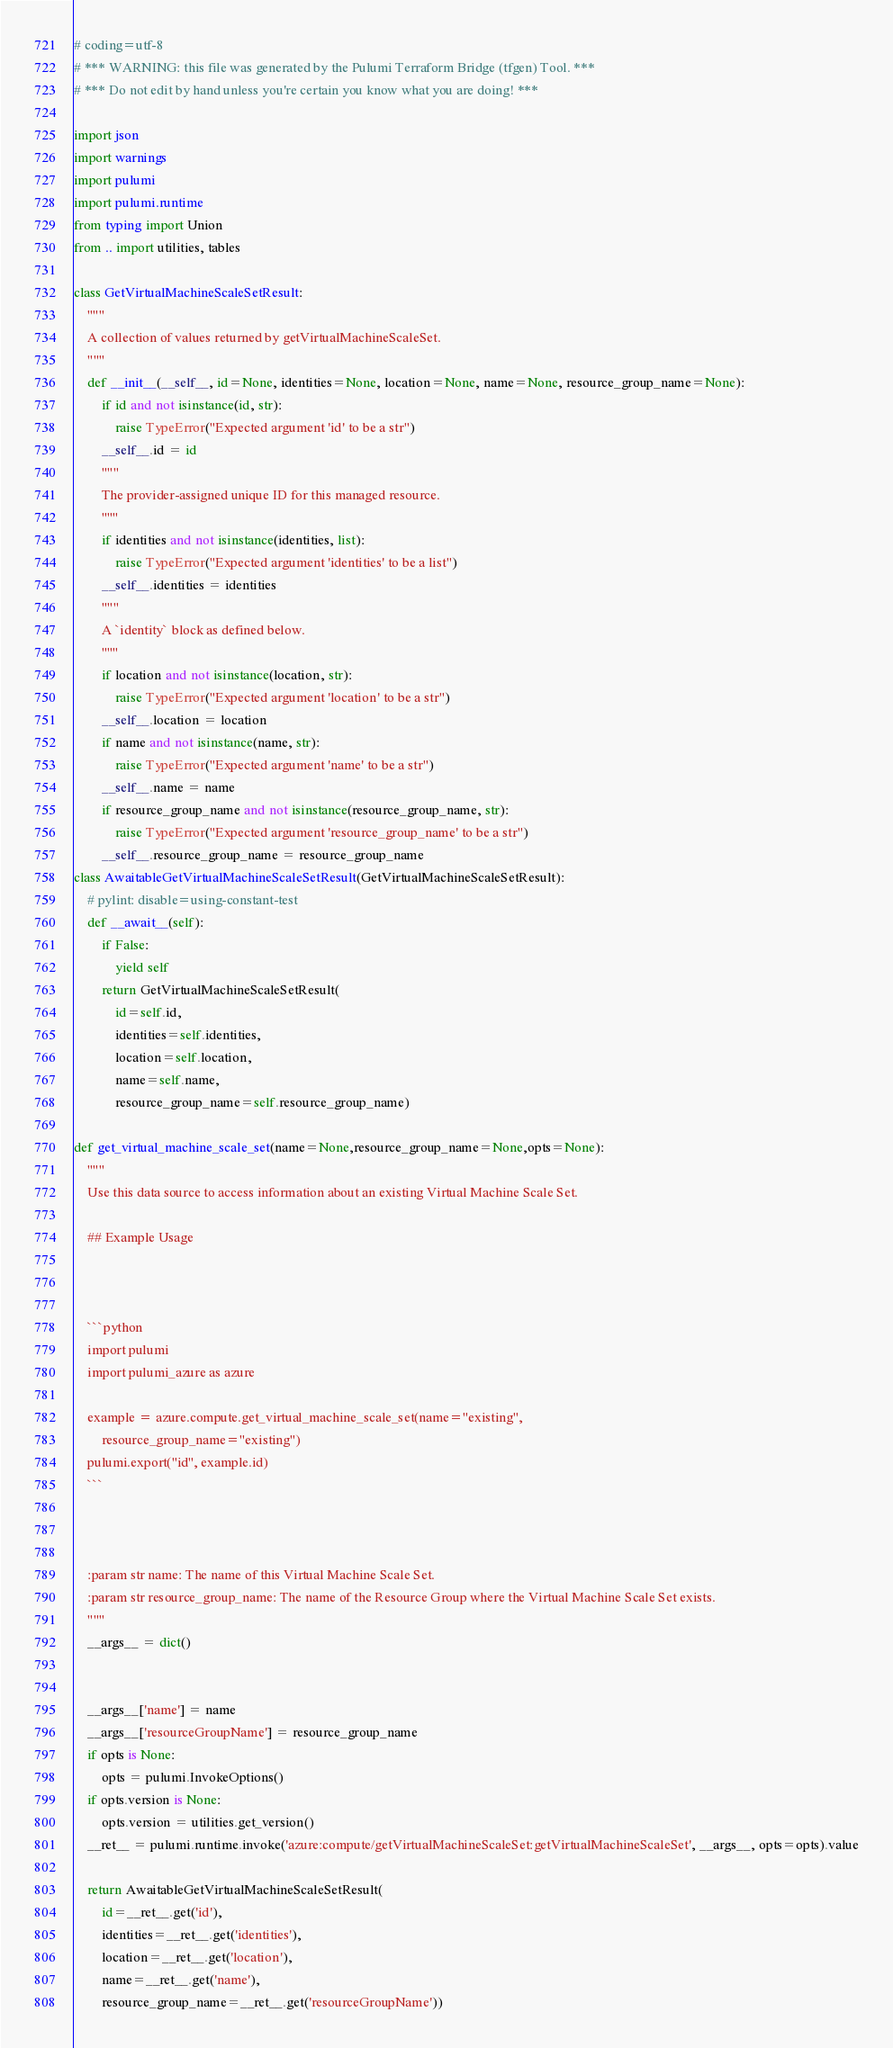Convert code to text. <code><loc_0><loc_0><loc_500><loc_500><_Python_># coding=utf-8
# *** WARNING: this file was generated by the Pulumi Terraform Bridge (tfgen) Tool. ***
# *** Do not edit by hand unless you're certain you know what you are doing! ***

import json
import warnings
import pulumi
import pulumi.runtime
from typing import Union
from .. import utilities, tables

class GetVirtualMachineScaleSetResult:
    """
    A collection of values returned by getVirtualMachineScaleSet.
    """
    def __init__(__self__, id=None, identities=None, location=None, name=None, resource_group_name=None):
        if id and not isinstance(id, str):
            raise TypeError("Expected argument 'id' to be a str")
        __self__.id = id
        """
        The provider-assigned unique ID for this managed resource.
        """
        if identities and not isinstance(identities, list):
            raise TypeError("Expected argument 'identities' to be a list")
        __self__.identities = identities
        """
        A `identity` block as defined below.
        """
        if location and not isinstance(location, str):
            raise TypeError("Expected argument 'location' to be a str")
        __self__.location = location
        if name and not isinstance(name, str):
            raise TypeError("Expected argument 'name' to be a str")
        __self__.name = name
        if resource_group_name and not isinstance(resource_group_name, str):
            raise TypeError("Expected argument 'resource_group_name' to be a str")
        __self__.resource_group_name = resource_group_name
class AwaitableGetVirtualMachineScaleSetResult(GetVirtualMachineScaleSetResult):
    # pylint: disable=using-constant-test
    def __await__(self):
        if False:
            yield self
        return GetVirtualMachineScaleSetResult(
            id=self.id,
            identities=self.identities,
            location=self.location,
            name=self.name,
            resource_group_name=self.resource_group_name)

def get_virtual_machine_scale_set(name=None,resource_group_name=None,opts=None):
    """
    Use this data source to access information about an existing Virtual Machine Scale Set.

    ## Example Usage



    ```python
    import pulumi
    import pulumi_azure as azure

    example = azure.compute.get_virtual_machine_scale_set(name="existing",
        resource_group_name="existing")
    pulumi.export("id", example.id)
    ```



    :param str name: The name of this Virtual Machine Scale Set.
    :param str resource_group_name: The name of the Resource Group where the Virtual Machine Scale Set exists.
    """
    __args__ = dict()


    __args__['name'] = name
    __args__['resourceGroupName'] = resource_group_name
    if opts is None:
        opts = pulumi.InvokeOptions()
    if opts.version is None:
        opts.version = utilities.get_version()
    __ret__ = pulumi.runtime.invoke('azure:compute/getVirtualMachineScaleSet:getVirtualMachineScaleSet', __args__, opts=opts).value

    return AwaitableGetVirtualMachineScaleSetResult(
        id=__ret__.get('id'),
        identities=__ret__.get('identities'),
        location=__ret__.get('location'),
        name=__ret__.get('name'),
        resource_group_name=__ret__.get('resourceGroupName'))
</code> 